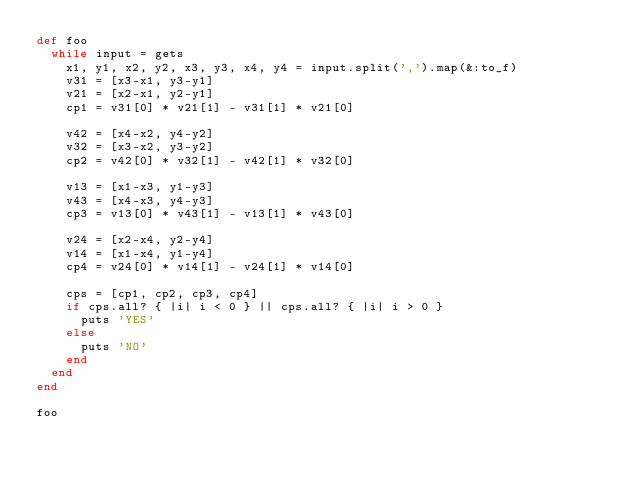<code> <loc_0><loc_0><loc_500><loc_500><_Ruby_>def foo
  while input = gets
    x1, y1, x2, y2, x3, y3, x4, y4 = input.split(',').map(&:to_f)
    v31 = [x3-x1, y3-y1]
    v21 = [x2-x1, y2-y1]
    cp1 = v31[0] * v21[1] - v31[1] * v21[0]

    v42 = [x4-x2, y4-y2]
    v32 = [x3-x2, y3-y2]
    cp2 = v42[0] * v32[1] - v42[1] * v32[0]

    v13 = [x1-x3, y1-y3]
    v43 = [x4-x3, y4-y3]
    cp3 = v13[0] * v43[1] - v13[1] * v43[0]

    v24 = [x2-x4, y2-y4]
    v14 = [x1-x4, y1-y4]
    cp4 = v24[0] * v14[1] - v24[1] * v14[0]

    cps = [cp1, cp2, cp3, cp4]
    if cps.all? { |i| i < 0 } || cps.all? { |i| i > 0 }
      puts 'YES'
    else
      puts 'NO'
    end
  end
end

foo</code> 